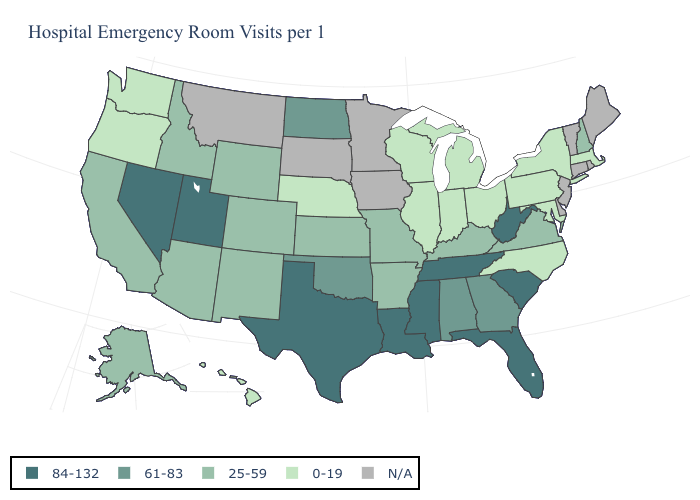Name the states that have a value in the range 0-19?
Give a very brief answer. Hawaii, Illinois, Indiana, Maryland, Massachusetts, Michigan, Nebraska, New York, North Carolina, Ohio, Oregon, Pennsylvania, Washington, Wisconsin. Name the states that have a value in the range 84-132?
Write a very short answer. Florida, Louisiana, Mississippi, Nevada, South Carolina, Tennessee, Texas, Utah, West Virginia. Name the states that have a value in the range 25-59?
Concise answer only. Alaska, Arizona, Arkansas, California, Colorado, Idaho, Kansas, Kentucky, Missouri, New Hampshire, New Mexico, Virginia, Wyoming. Does the map have missing data?
Write a very short answer. Yes. Which states have the highest value in the USA?
Be succinct. Florida, Louisiana, Mississippi, Nevada, South Carolina, Tennessee, Texas, Utah, West Virginia. Which states have the lowest value in the USA?
Concise answer only. Hawaii, Illinois, Indiana, Maryland, Massachusetts, Michigan, Nebraska, New York, North Carolina, Ohio, Oregon, Pennsylvania, Washington, Wisconsin. What is the lowest value in the USA?
Write a very short answer. 0-19. Among the states that border Maryland , does Pennsylvania have the highest value?
Write a very short answer. No. Among the states that border Tennessee , does Kentucky have the lowest value?
Be succinct. No. Does the map have missing data?
Keep it brief. Yes. Among the states that border Vermont , which have the lowest value?
Write a very short answer. Massachusetts, New York. Name the states that have a value in the range 61-83?
Answer briefly. Alabama, Georgia, North Dakota, Oklahoma. What is the value of Illinois?
Write a very short answer. 0-19. 